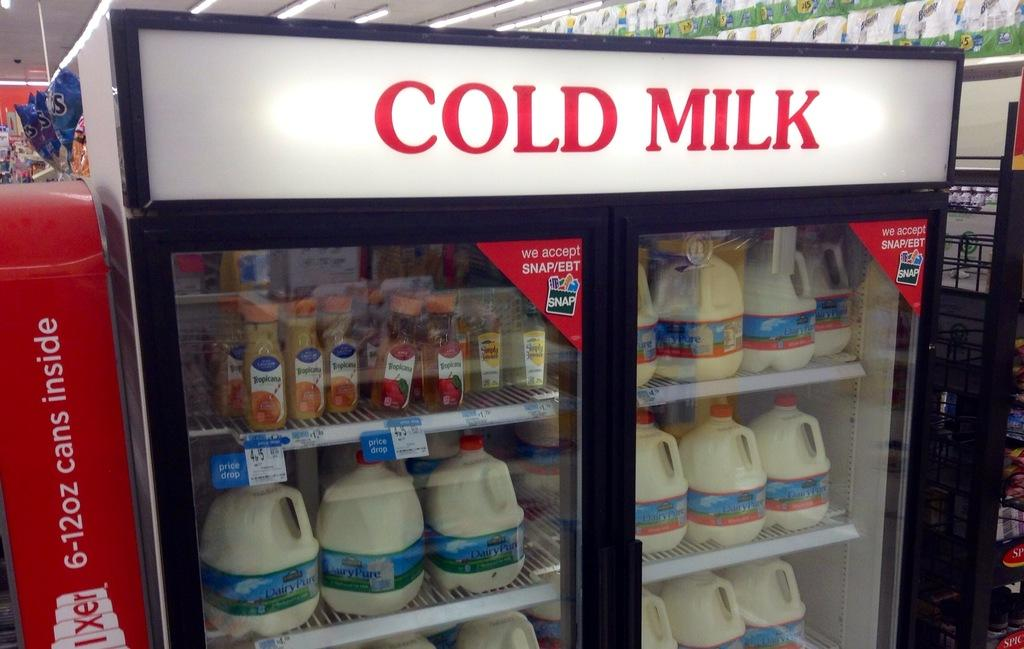<image>
Share a concise interpretation of the image provided. A refrigerated cabinet containing mostly "Dairy Pure" milk 